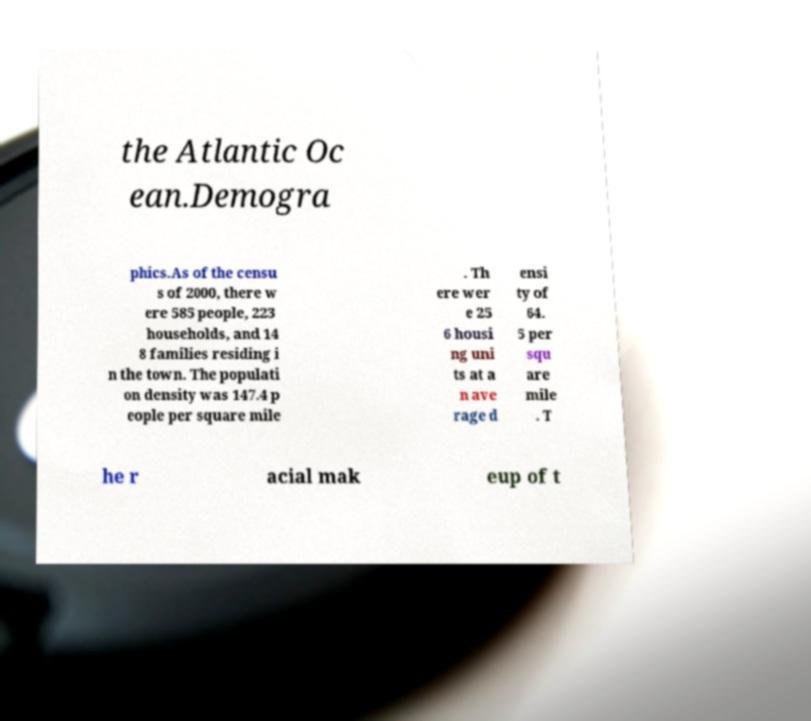Please read and relay the text visible in this image. What does it say? the Atlantic Oc ean.Demogra phics.As of the censu s of 2000, there w ere 585 people, 223 households, and 14 8 families residing i n the town. The populati on density was 147.4 p eople per square mile . Th ere wer e 25 6 housi ng uni ts at a n ave rage d ensi ty of 64. 5 per squ are mile . T he r acial mak eup of t 